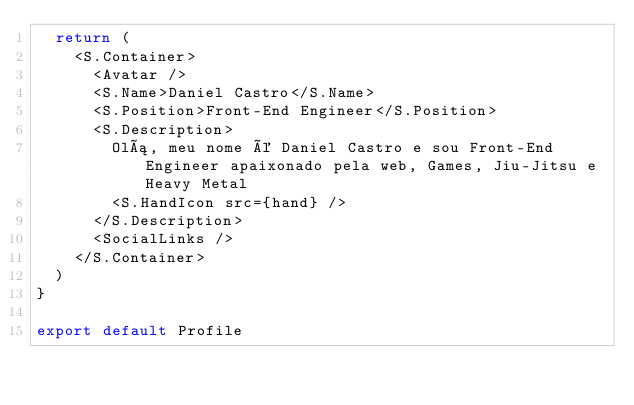Convert code to text. <code><loc_0><loc_0><loc_500><loc_500><_JavaScript_>  return (
    <S.Container>
      <Avatar />
      <S.Name>Daniel Castro</S.Name>
      <S.Position>Front-End Engineer</S.Position>
      <S.Description>
        Olá, meu nome é Daniel Castro e sou Front-End Engineer apaixonado pela web, Games, Jiu-Jitsu e Heavy Metal
        <S.HandIcon src={hand} />
      </S.Description>
      <SocialLinks />
    </S.Container>
  )
}

export default Profile</code> 